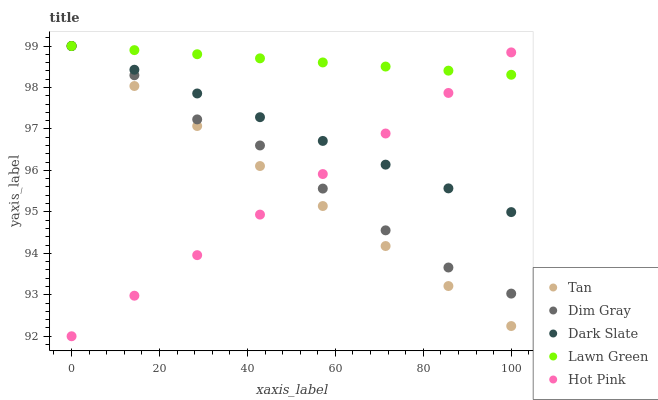Does Hot Pink have the minimum area under the curve?
Answer yes or no. Yes. Does Lawn Green have the maximum area under the curve?
Answer yes or no. Yes. Does Tan have the minimum area under the curve?
Answer yes or no. No. Does Tan have the maximum area under the curve?
Answer yes or no. No. Is Hot Pink the smoothest?
Answer yes or no. Yes. Is Dim Gray the roughest?
Answer yes or no. Yes. Is Tan the smoothest?
Answer yes or no. No. Is Tan the roughest?
Answer yes or no. No. Does Hot Pink have the lowest value?
Answer yes or no. Yes. Does Tan have the lowest value?
Answer yes or no. No. Does Lawn Green have the highest value?
Answer yes or no. Yes. Does Hot Pink have the highest value?
Answer yes or no. No. Does Dark Slate intersect Hot Pink?
Answer yes or no. Yes. Is Dark Slate less than Hot Pink?
Answer yes or no. No. Is Dark Slate greater than Hot Pink?
Answer yes or no. No. 